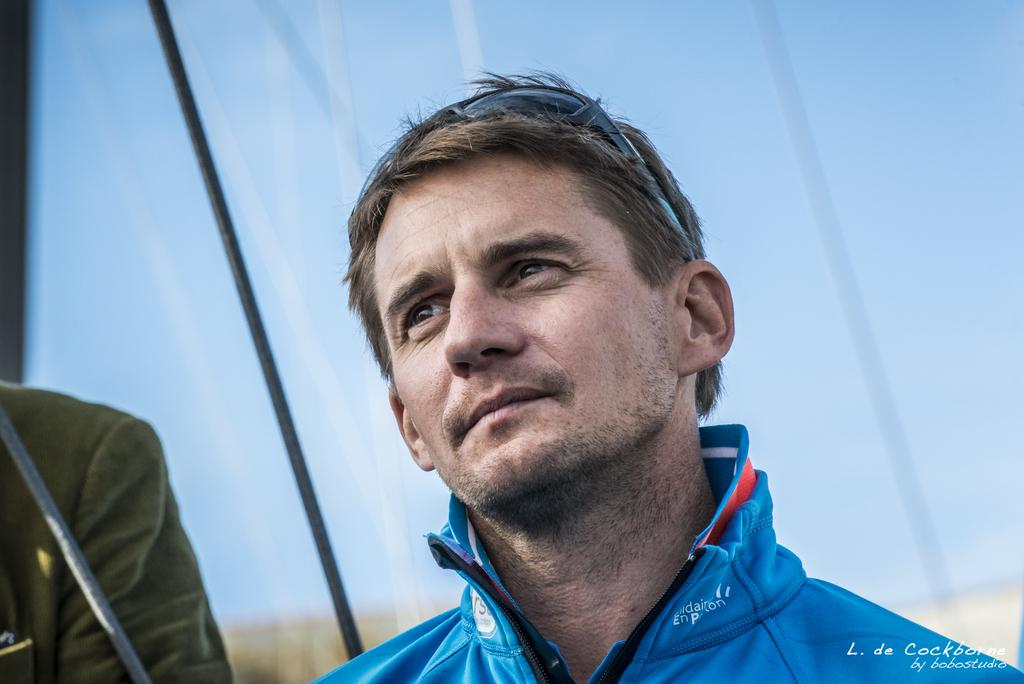Who or what is present in the image? There are people in the image. What objects can be seen in the image besides the people? There are ropes in the image. What part of the natural environment is visible in the image? The sky is visible in the image. Is there any text present in the image? Yes, there is some text at the bottom of the image. What type of juice is being sold at the price mentioned in the image? There is no juice or price mentioned in the image; it only contains people, ropes, the sky, and some text at the bottom. 